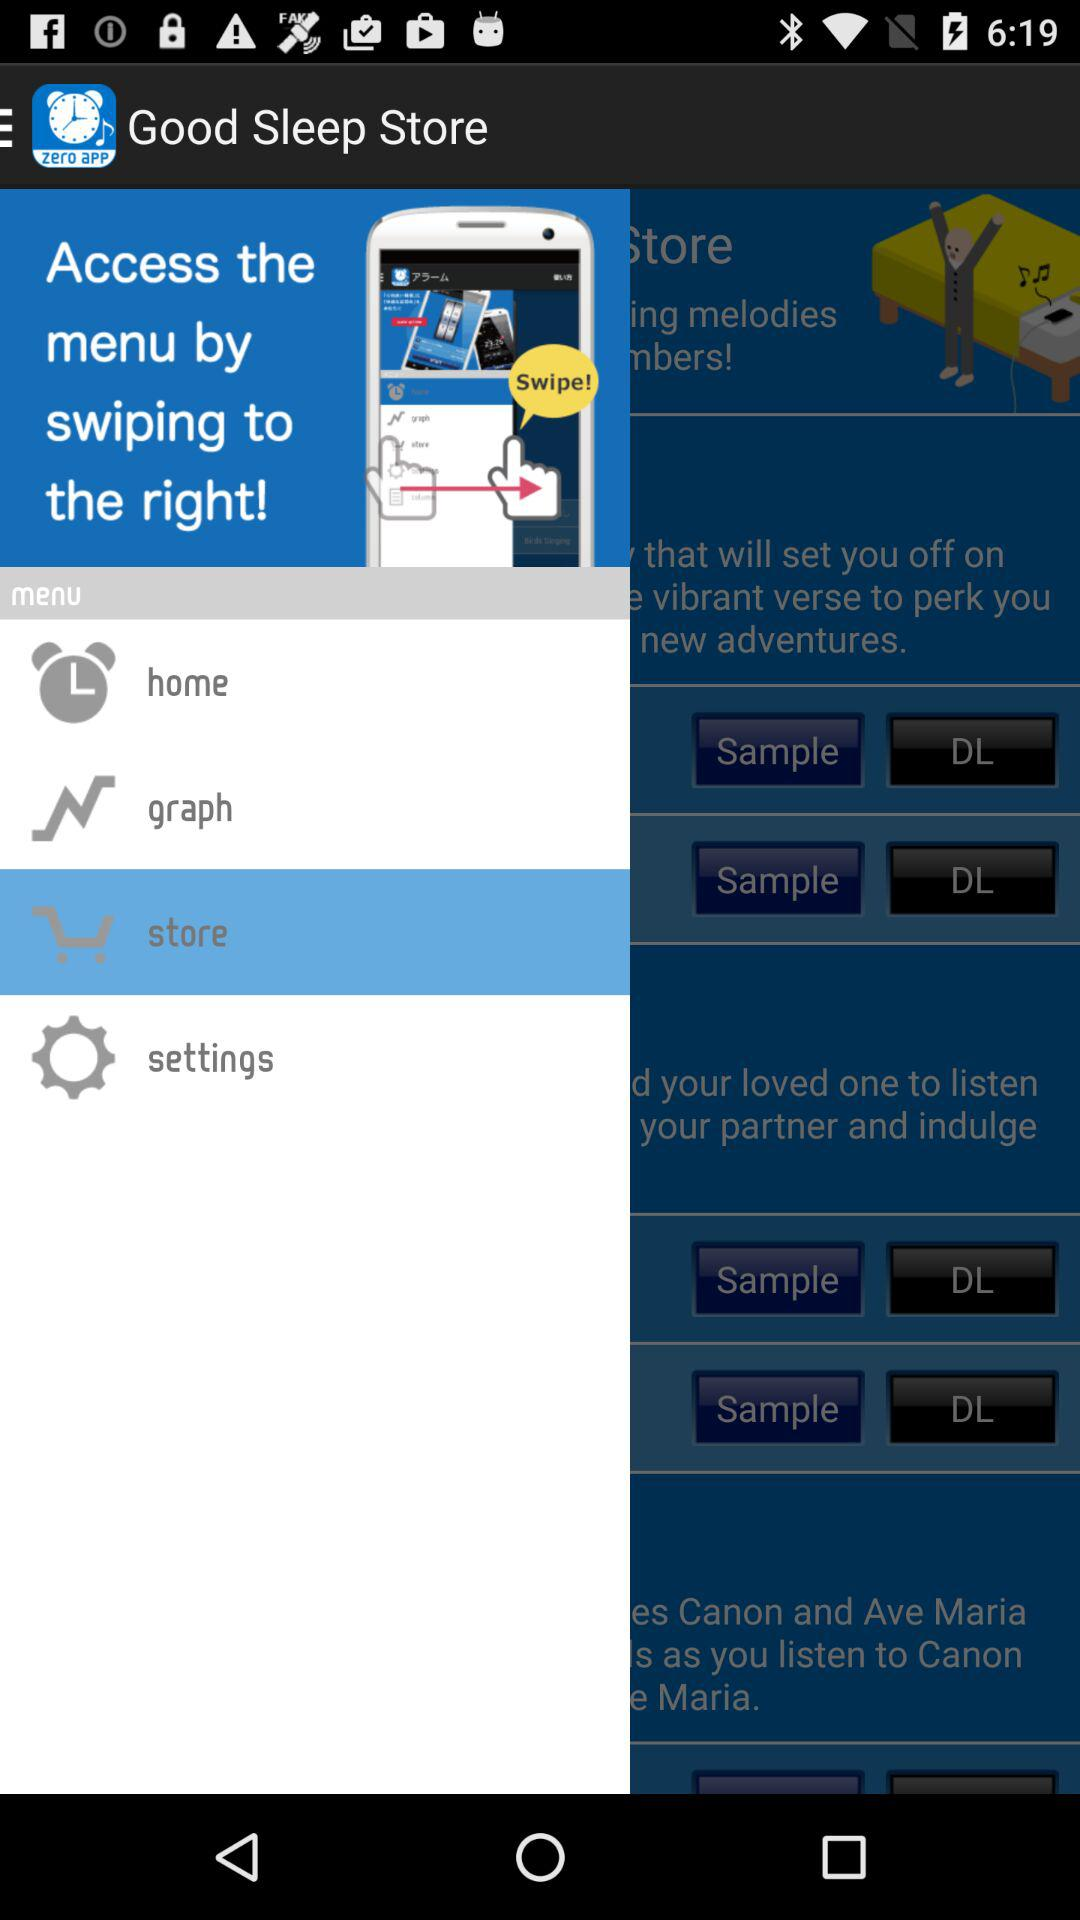What's the selected item in the menu? The selected item in the menu is "store". 